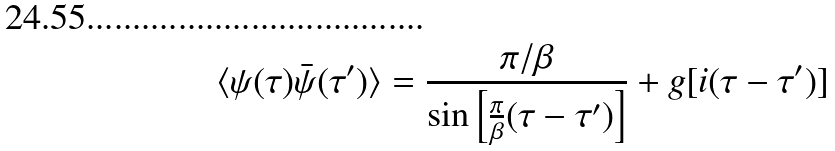<formula> <loc_0><loc_0><loc_500><loc_500>\langle \psi ( \tau ) \bar { \psi } ( \tau ^ { \prime } ) \rangle = \frac { \pi / \beta } { \sin \left [ \frac { \pi } { \beta } ( \tau - \tau ^ { \prime } ) \right ] } + g [ i ( \tau - \tau ^ { \prime } ) ]</formula> 